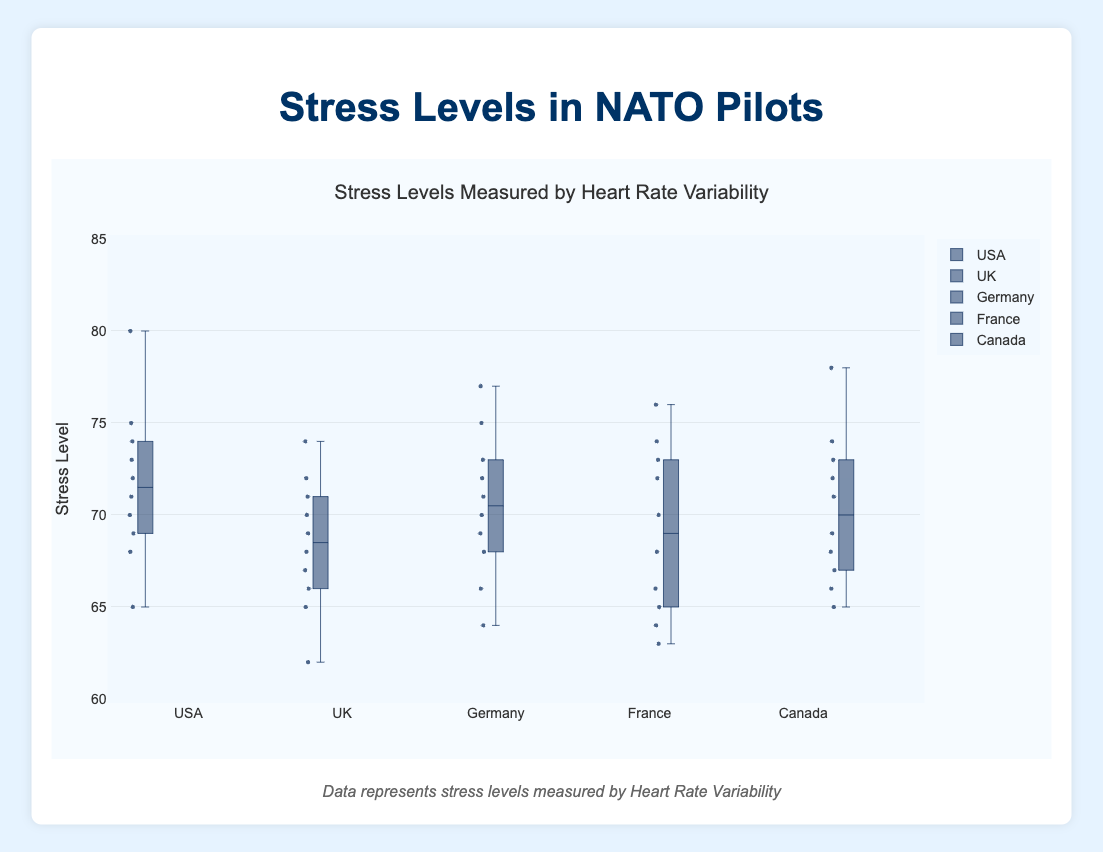What is the title of the figure? The title is displayed at the top of the figure and reads "Stress Levels Measured by Heart Rate Variability".
Answer: Stress Levels Measured by Heart Rate Variability Which country has the widest interquartile range (IQR)? The interquartile range (IQR) is the range between the first quartile (Q1) and the third quartile (Q3). Observing the boxplots, the country with the widest IQR has the largest box.
Answer: Germany What's the median stress level for pilots from the UK? The median value of a box plot is represented by the line inside the box. By looking at the UK box plot, the median stress level is where this line is positioned.
Answer: 68.5 How many countries are represented in the figure? Counting the number of individual box plots gives the number of countries represented.
Answer: 5 Which country has the highest maximum stress level recorded? The maximum value for each country is represented by the top whisker or point. The tallest whisker indicates the highest maximum.
Answer: USA Compare the median stress level of pilots from France and Germany; which one is higher? Look at the line inside the boxes for France and Germany; the higher median value indicates the country with the higher median stress level.
Answer: Germany What is the lower quartile (Q1) for the USA? Q1 is the bottom line of the box. For the USA, this value is where the bottom of the box is positioned.
Answer: 69 What is the difference between the highest and lowest stress levels in Canada? The highest and lowest stress levels for Canada are found at the top and bottom whiskers or points. Subtract the lowest value from the highest value.
Answer: 78 - 65 = 13 Which country has the smallest range of stress levels? The range is the difference between the maximum and minimum values. The smallest range is where the maximum and minimum are closest together.
Answer: UK Is there any overlap in the interquartile ranges (IQR) of the USA and Canada? Overlap in IQRs is seen if the boxes of the two countries intersect along the y-axis.
Answer: Yes 